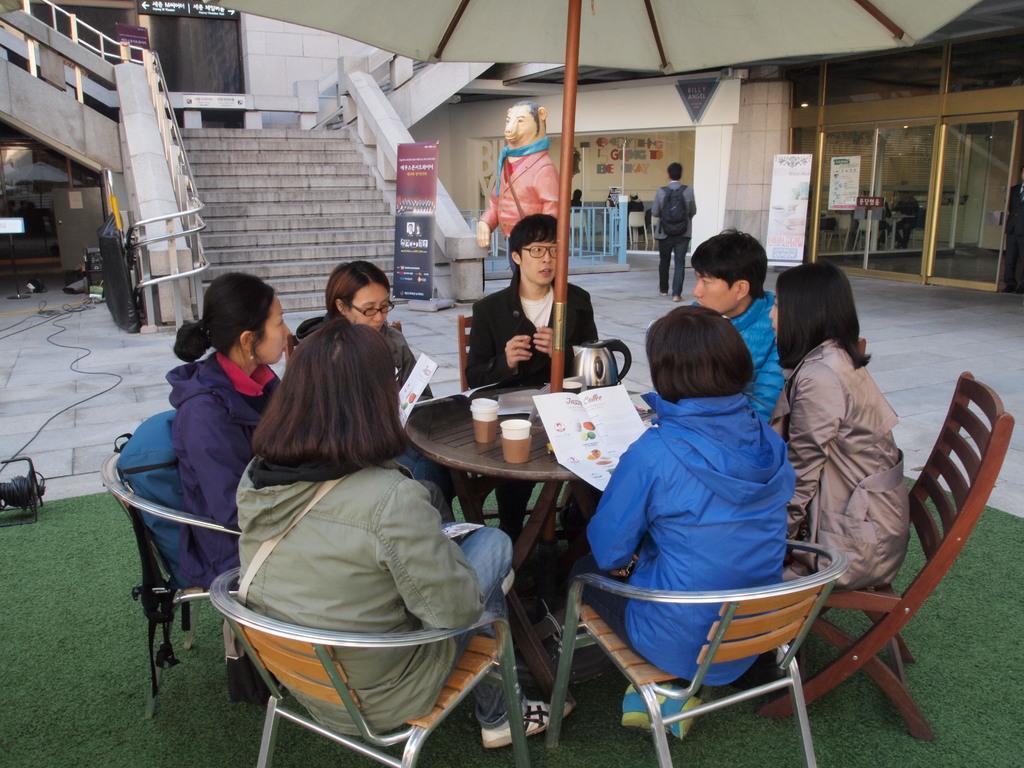Can you describe this image briefly? There are few people around the table sitting on the chair. In the background a person is wearing bag and walking on the floor. 